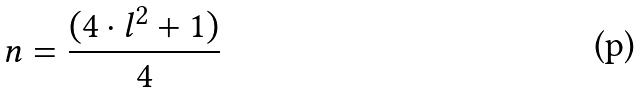Convert formula to latex. <formula><loc_0><loc_0><loc_500><loc_500>n = \frac { ( 4 \cdot l ^ { 2 } + 1 ) } { 4 }</formula> 